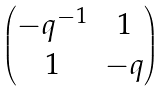<formula> <loc_0><loc_0><loc_500><loc_500>\begin{pmatrix} - q ^ { - 1 } & 1 \\ 1 & - q \\ \end{pmatrix}</formula> 